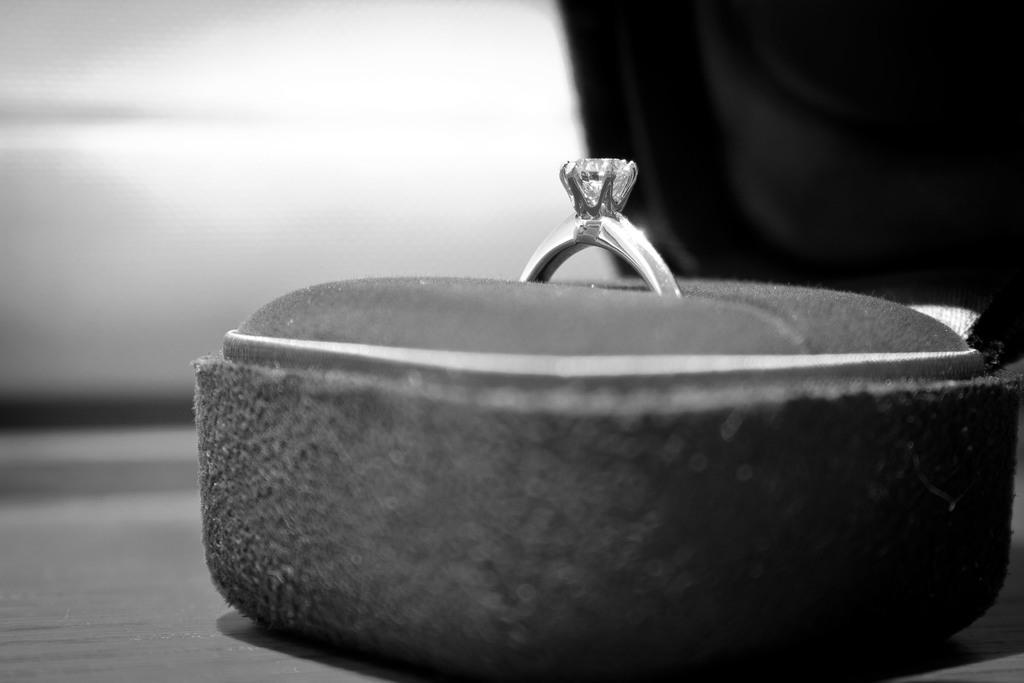Could you give a brief overview of what you see in this image? In this picture we can see a box on the surface with a ring in it and in the background it is blurry. 